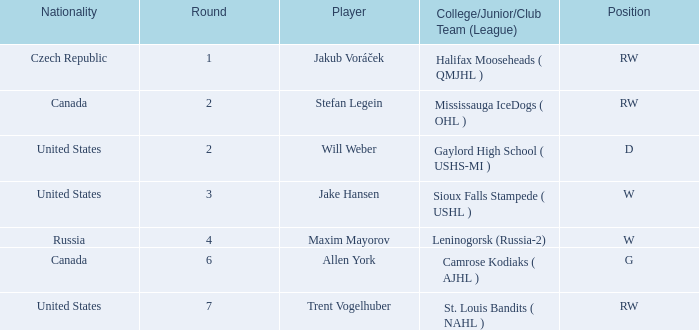What college or league did the round 2 pick with d position come from? Gaylord High School ( USHS-MI ). 